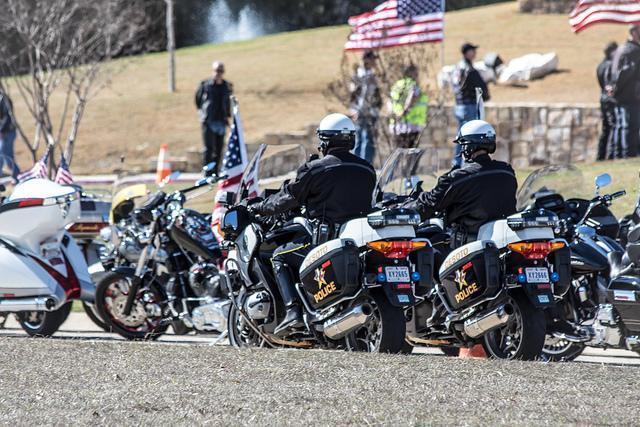How many people can be seen?
Give a very brief answer. 6. How many motorcycles can you see?
Give a very brief answer. 6. How many boats are there?
Give a very brief answer. 0. 